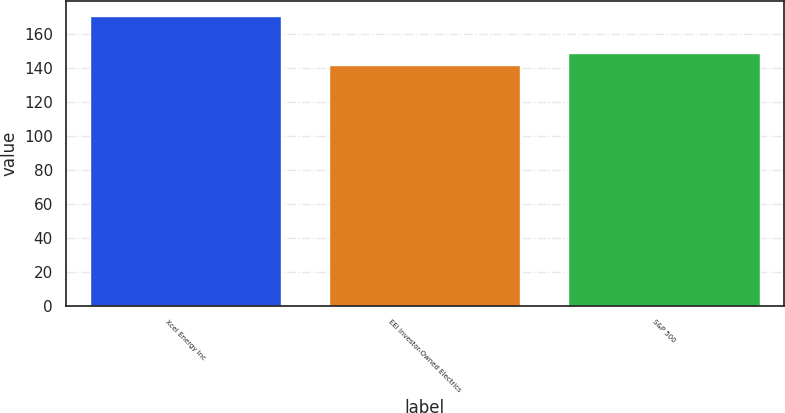<chart> <loc_0><loc_0><loc_500><loc_500><bar_chart><fcel>Xcel Energy Inc<fcel>EEI Investor-Owned Electrics<fcel>S&P 500<nl><fcel>171<fcel>142<fcel>149<nl></chart> 